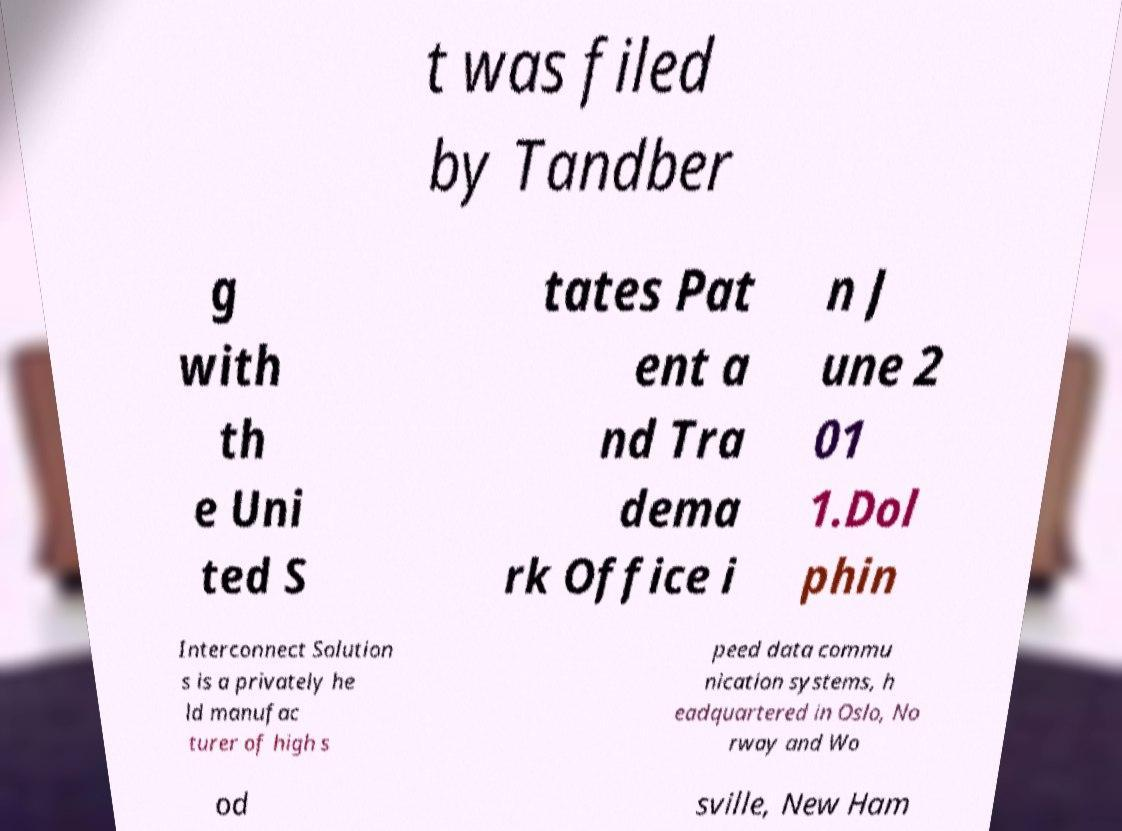Please identify and transcribe the text found in this image. t was filed by Tandber g with th e Uni ted S tates Pat ent a nd Tra dema rk Office i n J une 2 01 1.Dol phin Interconnect Solution s is a privately he ld manufac turer of high s peed data commu nication systems, h eadquartered in Oslo, No rway and Wo od sville, New Ham 